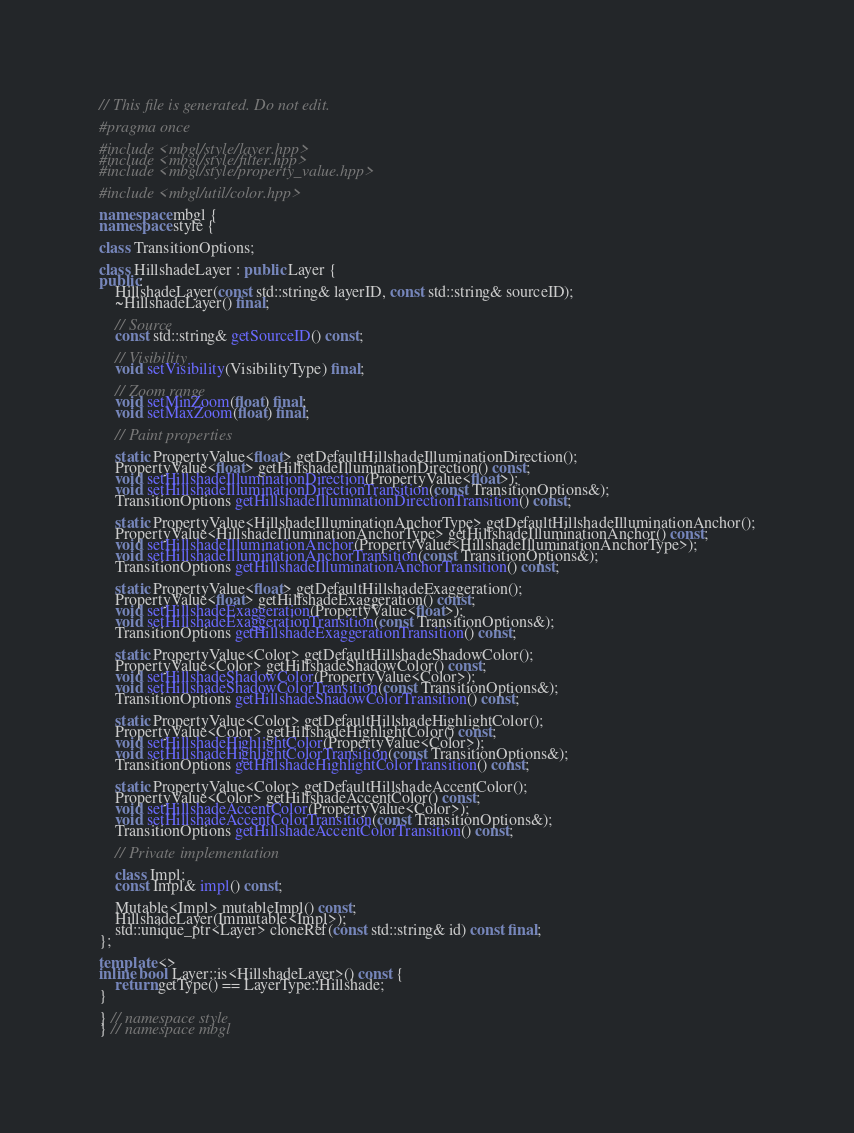<code> <loc_0><loc_0><loc_500><loc_500><_C++_>// This file is generated. Do not edit.

#pragma once

#include <mbgl/style/layer.hpp>
#include <mbgl/style/filter.hpp>
#include <mbgl/style/property_value.hpp>

#include <mbgl/util/color.hpp>

namespace mbgl {
namespace style {

class TransitionOptions;

class HillshadeLayer : public Layer {
public:
    HillshadeLayer(const std::string& layerID, const std::string& sourceID);
    ~HillshadeLayer() final;

    // Source
    const std::string& getSourceID() const;

    // Visibility
    void setVisibility(VisibilityType) final;

    // Zoom range
    void setMinZoom(float) final;
    void setMaxZoom(float) final;

    // Paint properties

    static PropertyValue<float> getDefaultHillshadeIlluminationDirection();
    PropertyValue<float> getHillshadeIlluminationDirection() const;
    void setHillshadeIlluminationDirection(PropertyValue<float>);
    void setHillshadeIlluminationDirectionTransition(const TransitionOptions&);
    TransitionOptions getHillshadeIlluminationDirectionTransition() const;

    static PropertyValue<HillshadeIlluminationAnchorType> getDefaultHillshadeIlluminationAnchor();
    PropertyValue<HillshadeIlluminationAnchorType> getHillshadeIlluminationAnchor() const;
    void setHillshadeIlluminationAnchor(PropertyValue<HillshadeIlluminationAnchorType>);
    void setHillshadeIlluminationAnchorTransition(const TransitionOptions&);
    TransitionOptions getHillshadeIlluminationAnchorTransition() const;

    static PropertyValue<float> getDefaultHillshadeExaggeration();
    PropertyValue<float> getHillshadeExaggeration() const;
    void setHillshadeExaggeration(PropertyValue<float>);
    void setHillshadeExaggerationTransition(const TransitionOptions&);
    TransitionOptions getHillshadeExaggerationTransition() const;

    static PropertyValue<Color> getDefaultHillshadeShadowColor();
    PropertyValue<Color> getHillshadeShadowColor() const;
    void setHillshadeShadowColor(PropertyValue<Color>);
    void setHillshadeShadowColorTransition(const TransitionOptions&);
    TransitionOptions getHillshadeShadowColorTransition() const;

    static PropertyValue<Color> getDefaultHillshadeHighlightColor();
    PropertyValue<Color> getHillshadeHighlightColor() const;
    void setHillshadeHighlightColor(PropertyValue<Color>);
    void setHillshadeHighlightColorTransition(const TransitionOptions&);
    TransitionOptions getHillshadeHighlightColorTransition() const;

    static PropertyValue<Color> getDefaultHillshadeAccentColor();
    PropertyValue<Color> getHillshadeAccentColor() const;
    void setHillshadeAccentColor(PropertyValue<Color>);
    void setHillshadeAccentColorTransition(const TransitionOptions&);
    TransitionOptions getHillshadeAccentColorTransition() const;

    // Private implementation

    class Impl;
    const Impl& impl() const;

    Mutable<Impl> mutableImpl() const;
    HillshadeLayer(Immutable<Impl>);
    std::unique_ptr<Layer> cloneRef(const std::string& id) const final;
};

template <>
inline bool Layer::is<HillshadeLayer>() const {
    return getType() == LayerType::Hillshade;
}

} // namespace style
} // namespace mbgl
</code> 